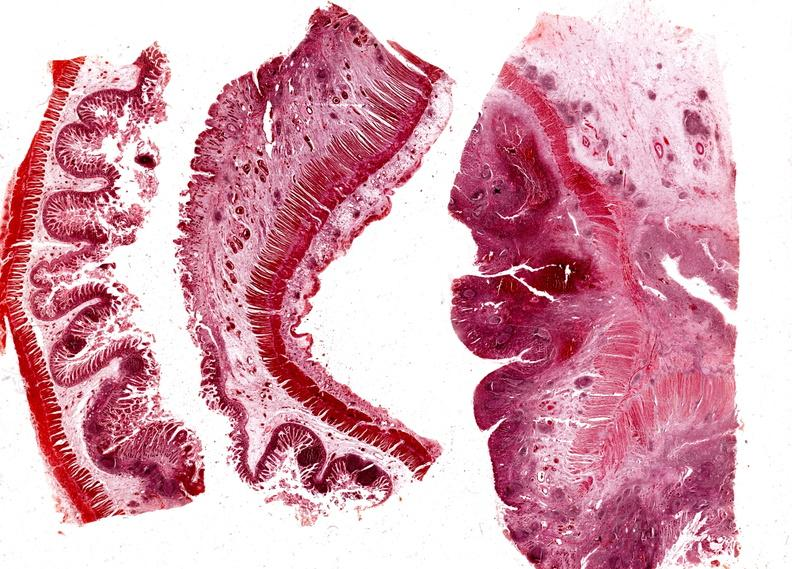s this image shows of smooth muscle cell with lipid in sarcoplasm and lipid present?
Answer the question using a single word or phrase. No 